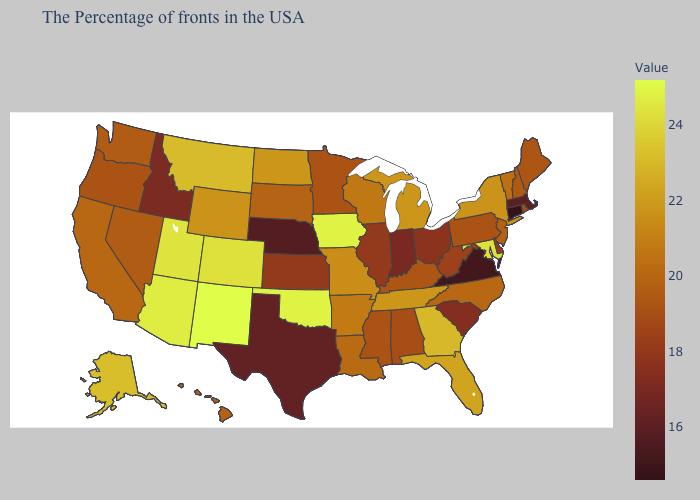Among the states that border Nebraska , does Wyoming have the lowest value?
Short answer required. No. Is the legend a continuous bar?
Answer briefly. Yes. Which states have the lowest value in the South?
Keep it brief. Virginia. Among the states that border New York , which have the highest value?
Give a very brief answer. Vermont. 